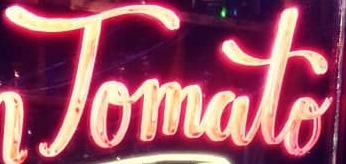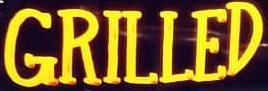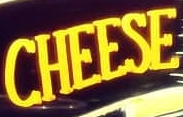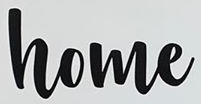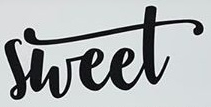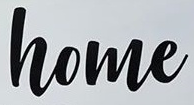What text is displayed in these images sequentially, separated by a semicolon? Tomato; GRILLED; CHEESE; home; sheet; home 